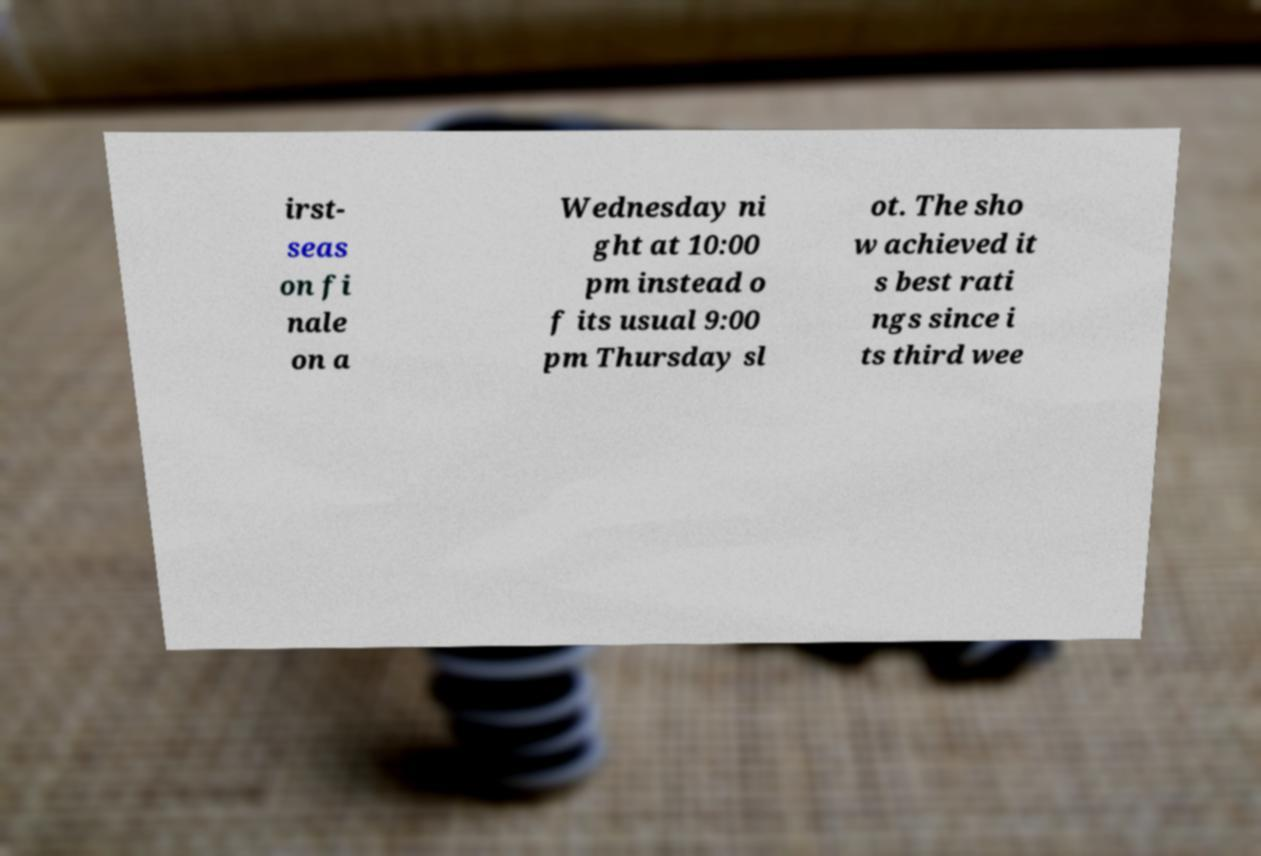What messages or text are displayed in this image? I need them in a readable, typed format. irst- seas on fi nale on a Wednesday ni ght at 10:00 pm instead o f its usual 9:00 pm Thursday sl ot. The sho w achieved it s best rati ngs since i ts third wee 